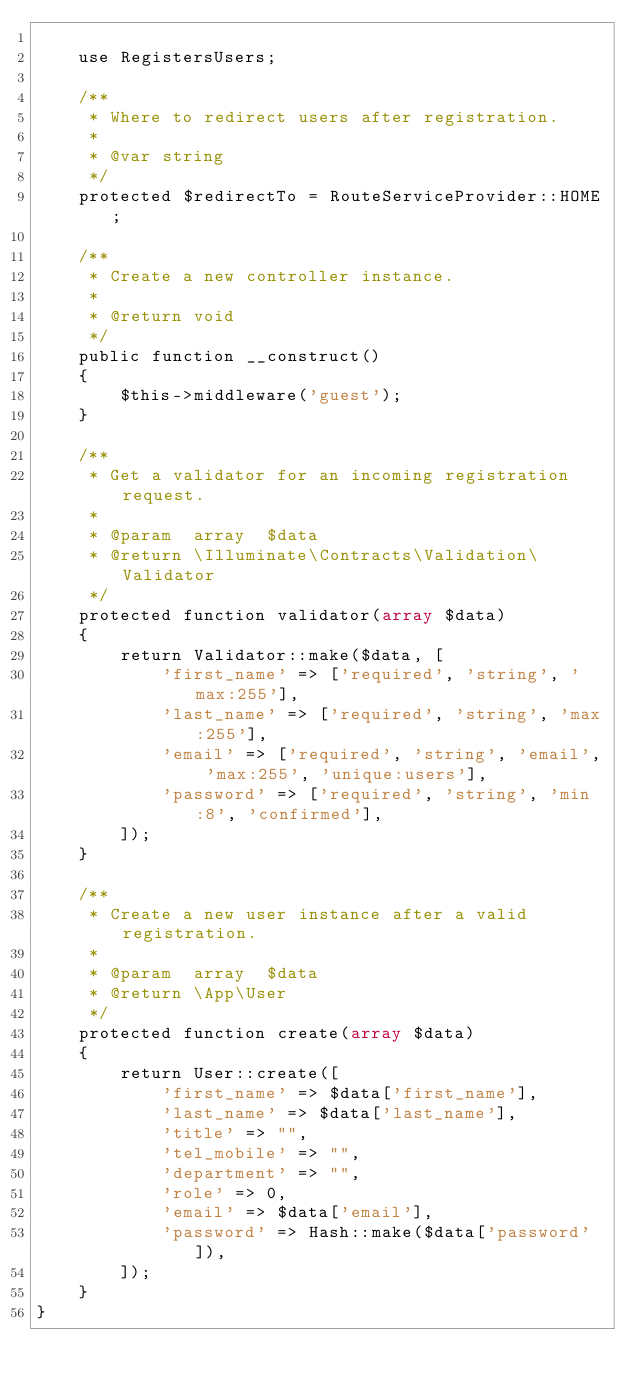Convert code to text. <code><loc_0><loc_0><loc_500><loc_500><_PHP_>
    use RegistersUsers;

    /**
     * Where to redirect users after registration.
     *
     * @var string
     */
    protected $redirectTo = RouteServiceProvider::HOME;

    /**
     * Create a new controller instance.
     *
     * @return void
     */
    public function __construct()
    {
        $this->middleware('guest');
    }

    /**
     * Get a validator for an incoming registration request.
     *
     * @param  array  $data
     * @return \Illuminate\Contracts\Validation\Validator
     */
    protected function validator(array $data)
    {
        return Validator::make($data, [
            'first_name' => ['required', 'string', 'max:255'],
            'last_name' => ['required', 'string', 'max:255'],
            'email' => ['required', 'string', 'email', 'max:255', 'unique:users'],
            'password' => ['required', 'string', 'min:8', 'confirmed'],
        ]);
    }

    /**
     * Create a new user instance after a valid registration.
     *
     * @param  array  $data
     * @return \App\User
     */
    protected function create(array $data)
    {
        return User::create([
            'first_name' => $data['first_name'],
            'last_name' => $data['last_name'],
            'title' => "",
            'tel_mobile' => "",
            'department' => "",
            'role' => 0,
            'email' => $data['email'],
            'password' => Hash::make($data['password']),
        ]);
    }
}
</code> 